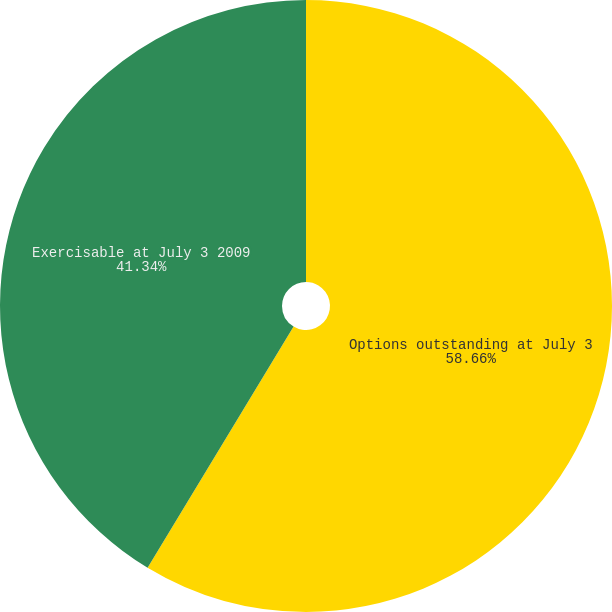Convert chart. <chart><loc_0><loc_0><loc_500><loc_500><pie_chart><fcel>Options outstanding at July 3<fcel>Exercisable at July 3 2009<nl><fcel>58.66%<fcel>41.34%<nl></chart> 